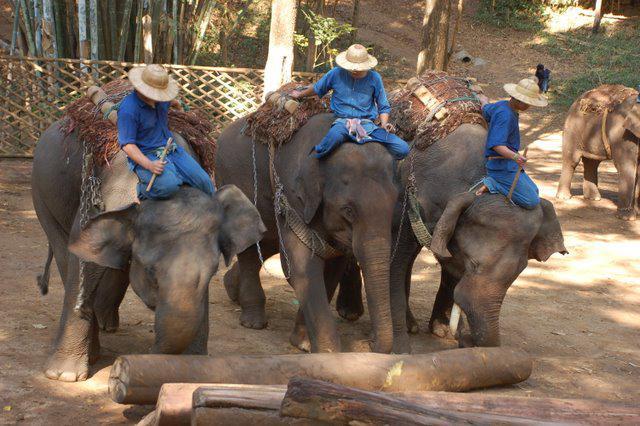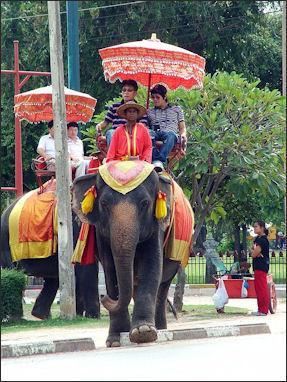The first image is the image on the left, the second image is the image on the right. Assess this claim about the two images: "the elephant on the right image is facing right.". Correct or not? Answer yes or no. No. 